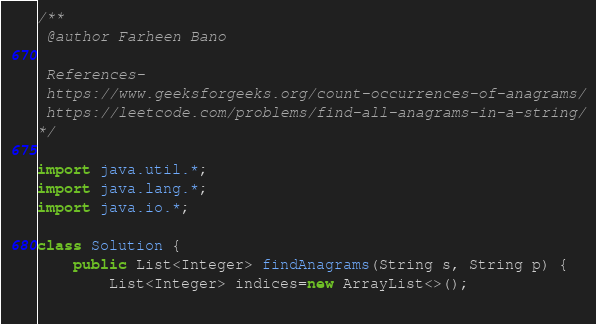<code> <loc_0><loc_0><loc_500><loc_500><_Java_>/**
 @author Farheen Bano
  
 References-
 https://www.geeksforgeeks.org/count-occurrences-of-anagrams/
 https://leetcode.com/problems/find-all-anagrams-in-a-string/
*/

import java.util.*;
import java.lang.*;
import java.io.*;

class Solution {
    public List<Integer> findAnagrams(String s, String p) {
        List<Integer> indices=new ArrayList<>();
        </code> 